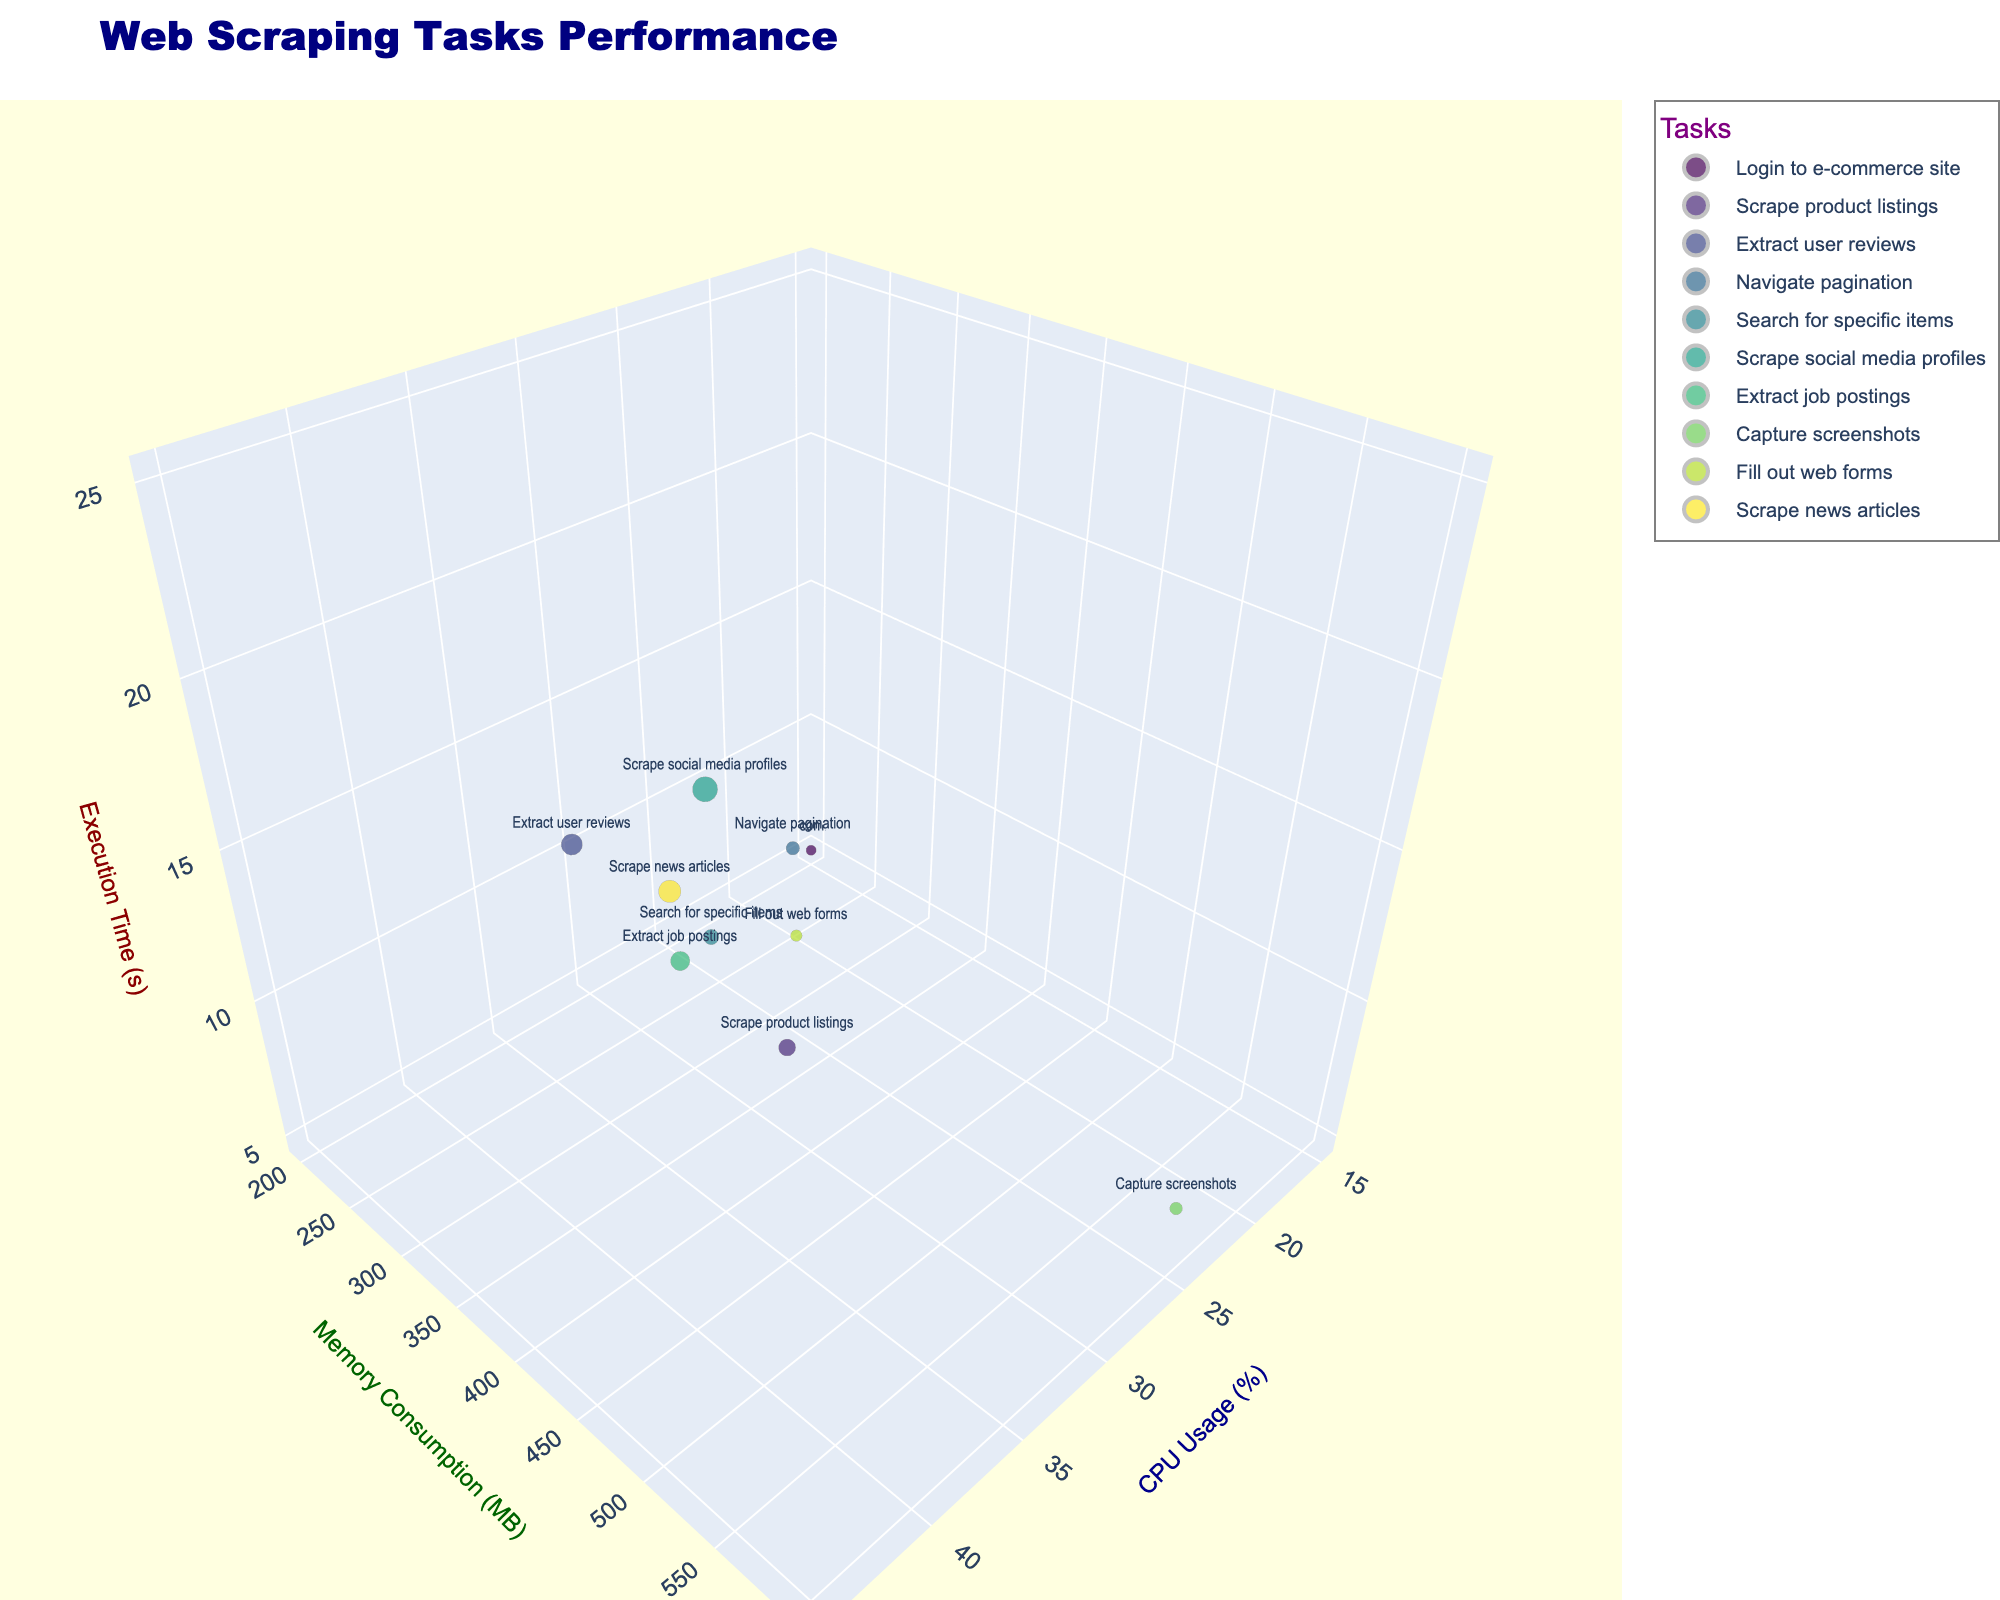What is the title of the chart? The title is a basic element that is prominently displayed at the top of the chart. In this case, the title is given and clearly states the chart's focus.
Answer: Web Scraping Tasks Performance Which task consumes the most memory? To determine which task consumes the most memory, look at the memory consumption axis and find the bubble at the highest position.
Answer: Capture screenshots What is the range of CPU usage shown in the chart? Examine the x-axis that represents CPU usage to find the minimum and maximum values.
Answer: 15% to 45% Which task has the longest execution time? Check the z-axis representing execution time and identify the highest bubble. This provides the task with the longest duration.
Answer: Scrape social media profiles How does the memory consumption of "Scrape product listings" compare to "Extract job postings"? Locate the bubbles for both tasks. Then compare their positions along the y-axis for memory consumption.
Answer: Scrape product listings has higher memory consumption than Extract job postings Which task has the smallest bubble size and what does it represent? Bubble size is normalized by execution time. Identify the smallest bubble to find the corresponding task.
Answer: Login to e-commerce site; it has the smallest execution time What are the average CPU usage and memory consumption for all tasks? Calculate the mean values by summing all the CPU usages and memory consumptions and dividing by the number of data points.
Answer: CPU: 31.2%, Memory: 393 MB What is the difference in execution time between "Scrape news articles" and "Login to e-commerce site"? Subtract the execution time of "Login to e-commerce site" from "Scrape news articles".
Answer: 15 seconds Is there a general trend between CPU usage and execution time? Observing the bubbles along the z-axis and x-axis, see if higher CPU usage corresponds to longer or shorter execution times.
Answer: Higher CPU usage generally corresponds to longer execution times What is the execution time for tasks with memory consumption close to 400 MB? Find the bubbles near the 400 MB mark on the y-axis and read their positions on the z-axis for execution time.
Answer: Extract user reviews (18 s) and Extract job postings (15 s) 